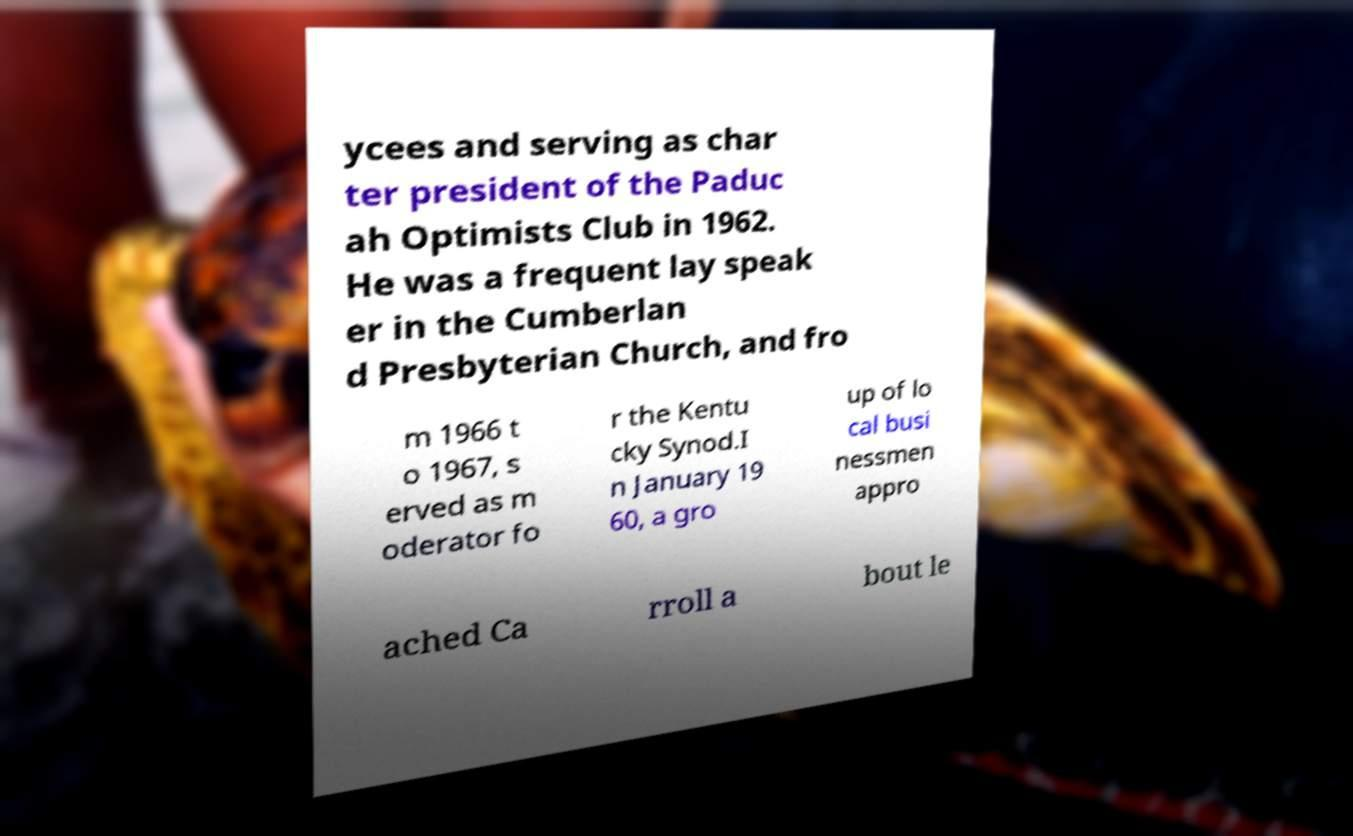Please read and relay the text visible in this image. What does it say? ycees and serving as char ter president of the Paduc ah Optimists Club in 1962. He was a frequent lay speak er in the Cumberlan d Presbyterian Church, and fro m 1966 t o 1967, s erved as m oderator fo r the Kentu cky Synod.I n January 19 60, a gro up of lo cal busi nessmen appro ached Ca rroll a bout le 